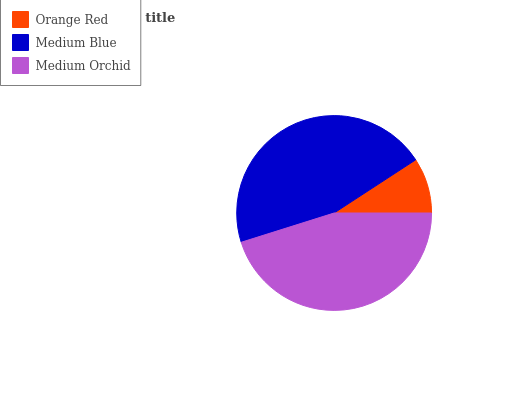Is Orange Red the minimum?
Answer yes or no. Yes. Is Medium Blue the maximum?
Answer yes or no. Yes. Is Medium Orchid the minimum?
Answer yes or no. No. Is Medium Orchid the maximum?
Answer yes or no. No. Is Medium Blue greater than Medium Orchid?
Answer yes or no. Yes. Is Medium Orchid less than Medium Blue?
Answer yes or no. Yes. Is Medium Orchid greater than Medium Blue?
Answer yes or no. No. Is Medium Blue less than Medium Orchid?
Answer yes or no. No. Is Medium Orchid the high median?
Answer yes or no. Yes. Is Medium Orchid the low median?
Answer yes or no. Yes. Is Orange Red the high median?
Answer yes or no. No. Is Orange Red the low median?
Answer yes or no. No. 